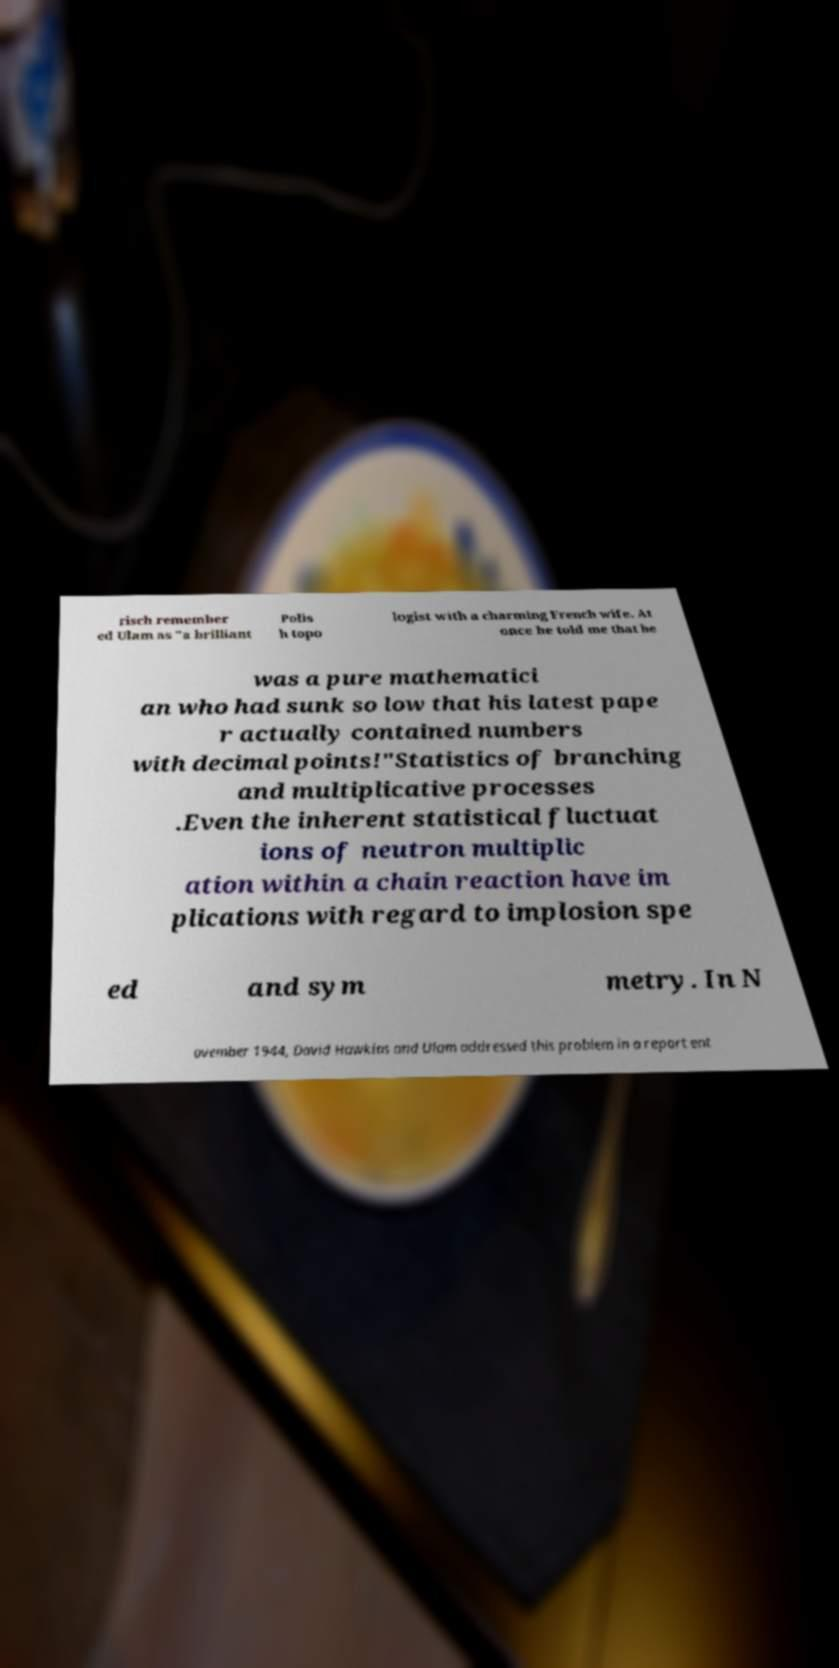Could you assist in decoding the text presented in this image and type it out clearly? risch remember ed Ulam as "a brilliant Polis h topo logist with a charming French wife. At once he told me that he was a pure mathematici an who had sunk so low that his latest pape r actually contained numbers with decimal points!"Statistics of branching and multiplicative processes .Even the inherent statistical fluctuat ions of neutron multiplic ation within a chain reaction have im plications with regard to implosion spe ed and sym metry. In N ovember 1944, David Hawkins and Ulam addressed this problem in a report ent 